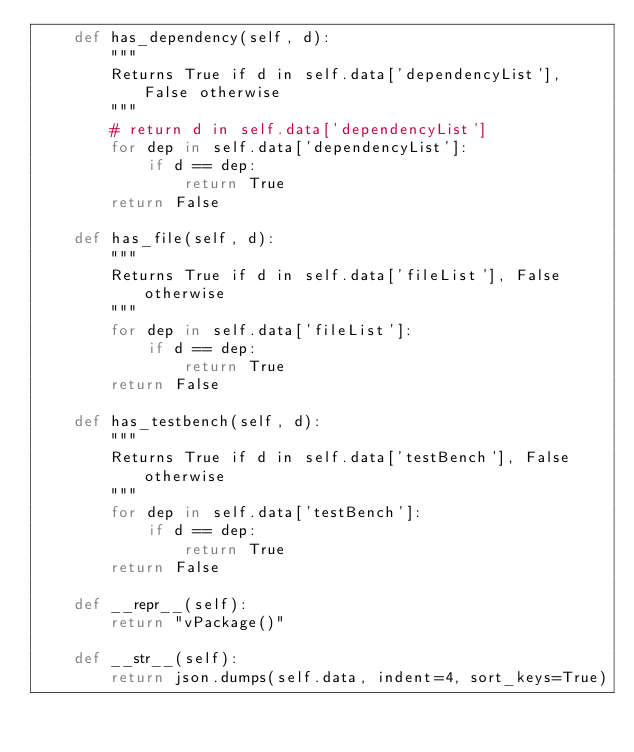Convert code to text. <code><loc_0><loc_0><loc_500><loc_500><_Python_>    def has_dependency(self, d):
        """
        Returns True if d in self.data['dependencyList'], False otherwise
        """
        # return d in self.data['dependencyList']
        for dep in self.data['dependencyList']:
            if d == dep:
                return True
        return False
    
    def has_file(self, d):
        """
        Returns True if d in self.data['fileList'], False otherwise
        """
        for dep in self.data['fileList']:
            if d == dep:
                return True
        return False
    
    def has_testbench(self, d):
        """
        Returns True if d in self.data['testBench'], False otherwise
        """
        for dep in self.data['testBench']:
            if d == dep:
                return True
        return False

    def __repr__(self):
        return "vPackage()"
    
    def __str__(self):
        return json.dumps(self.data, indent=4, sort_keys=True)
        </code> 